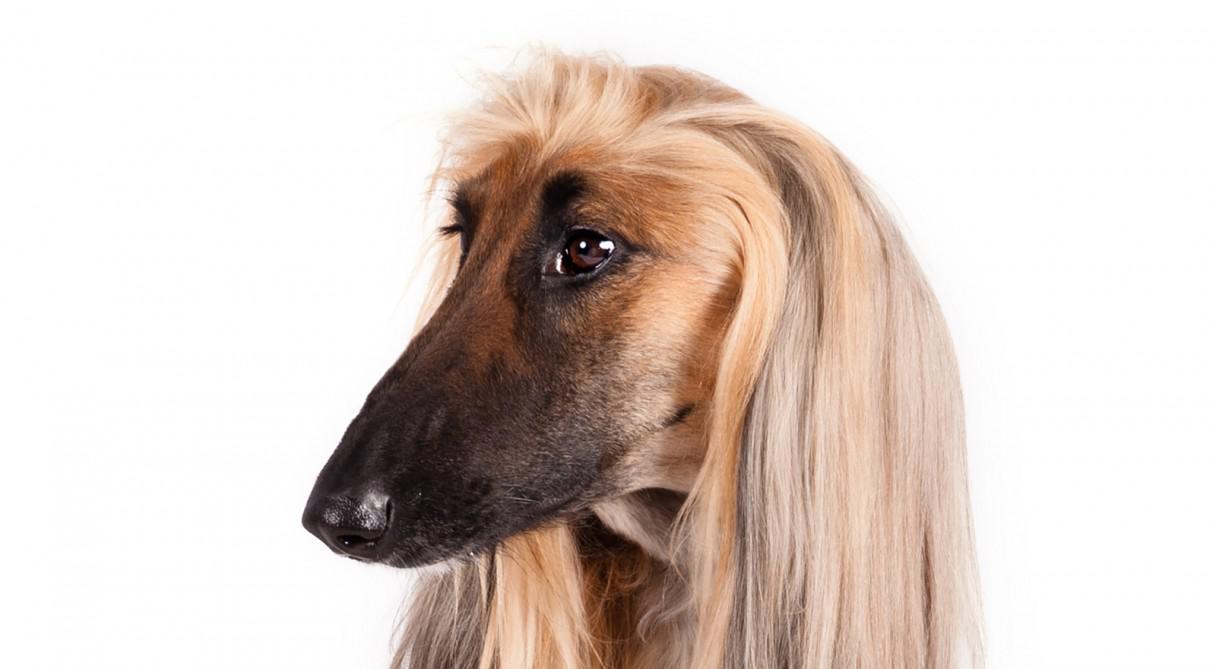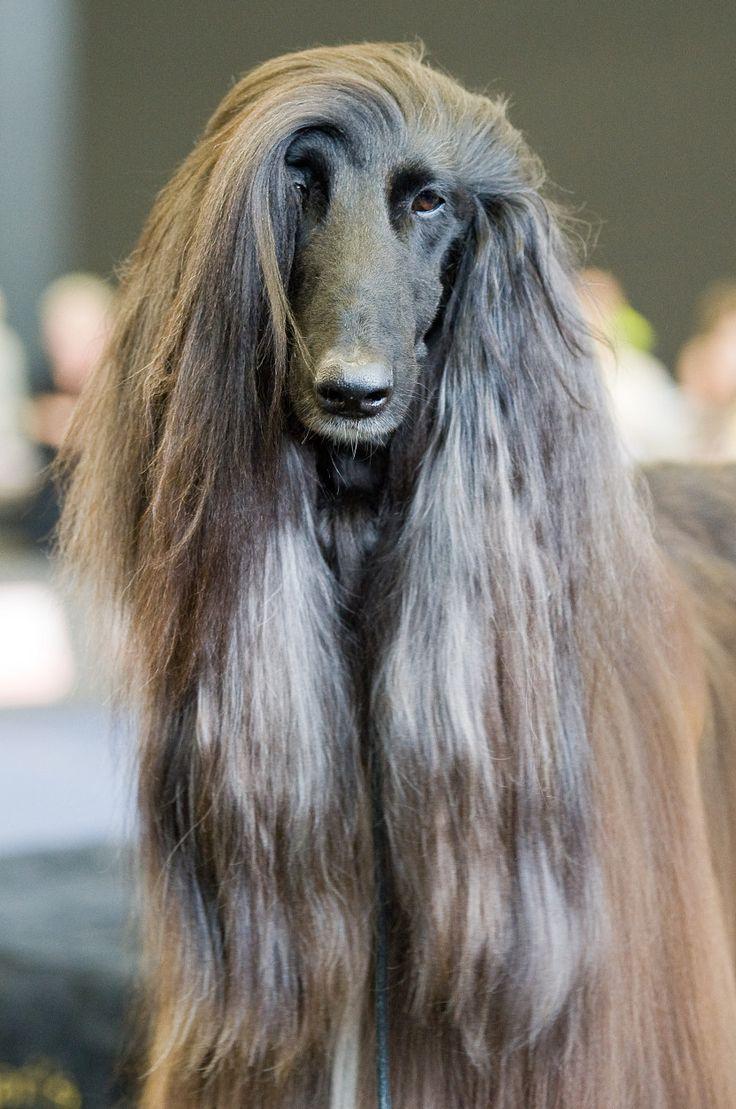The first image is the image on the left, the second image is the image on the right. Evaluate the accuracy of this statement regarding the images: "Both of the dogs are standing on the grass.". Is it true? Answer yes or no. No. 